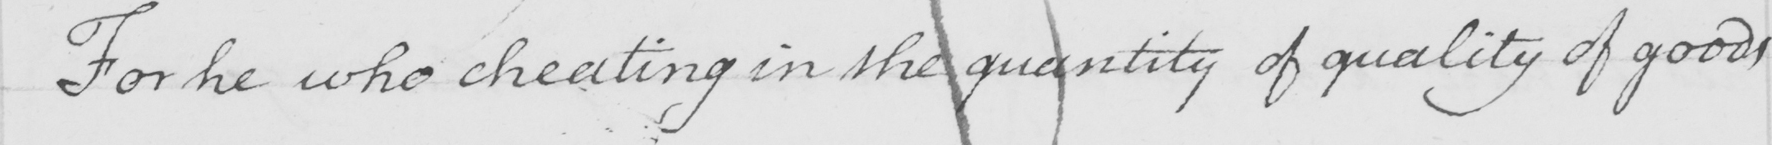Can you tell me what this handwritten text says? For he who cheating in the quantity of quality of goods 